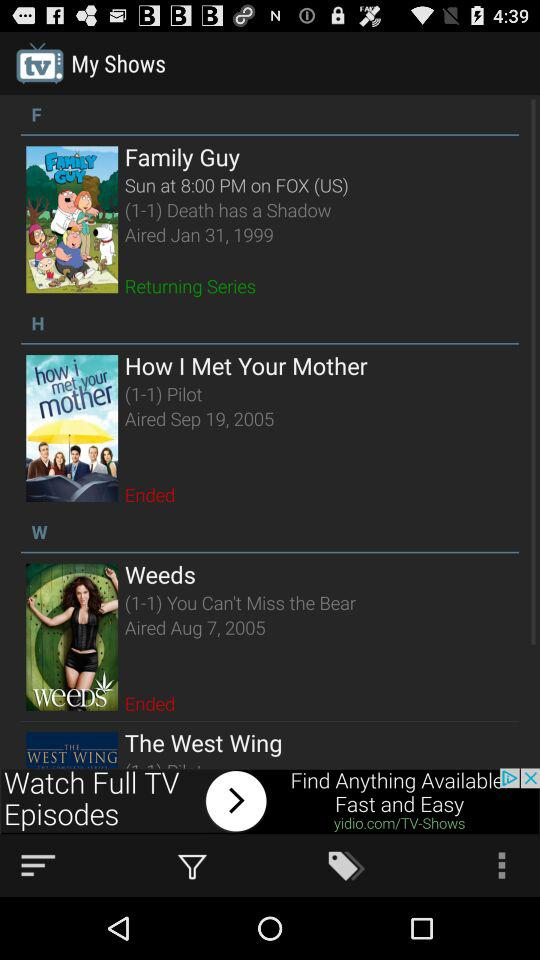What is the Aired date of the "Weeds" series? The Aired date is August 7, 2005. 